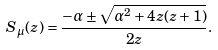Convert formula to latex. <formula><loc_0><loc_0><loc_500><loc_500>S _ { \mu } ( z ) = \frac { - \alpha \pm \sqrt { \alpha ^ { 2 } + 4 z ( z + 1 ) } } { 2 z } .</formula> 